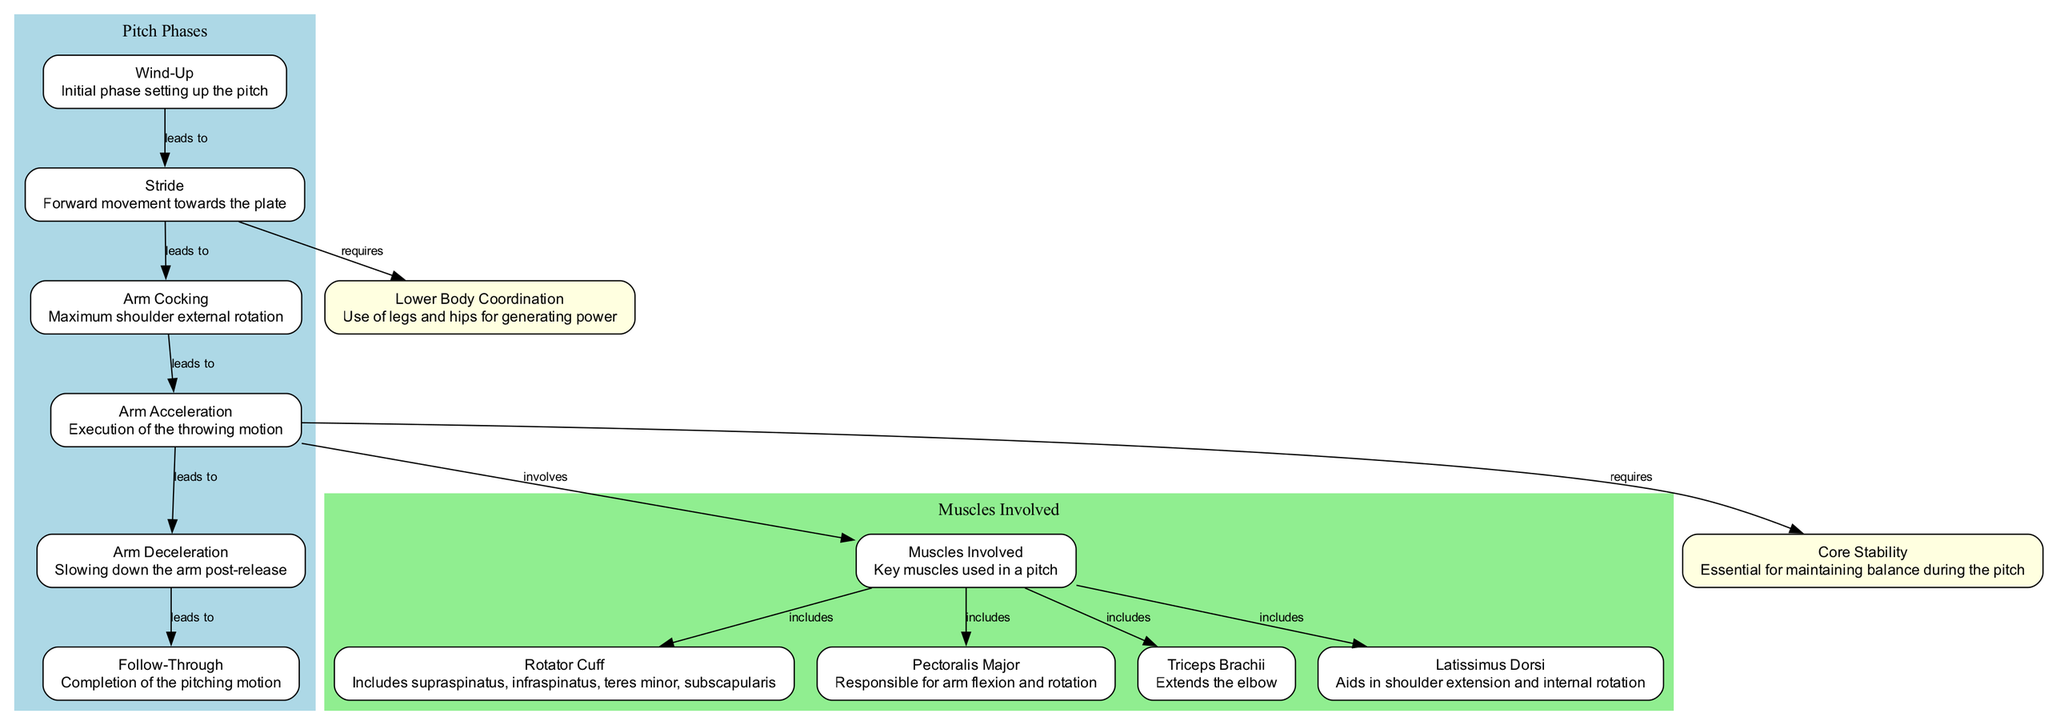What is the first phase of the pitch? The diagram identifies the first phase of the pitch as "Wind-Up," which prepares the body for the throwing motion.
Answer: Wind-Up How many muscles are included in the "Muscles Involved" section? The diagram lists four specific muscles under the "Muscles Involved" node, which are the Rotator Cuff, Pectoralis Major, Triceps Brachii, and Latissimus Dorsi.
Answer: Four What does "Arm Acceleration" lead to? According to the diagram, "Arm Acceleration" leads to "Arm Deceleration," indicating the next step in the pitching motion after acceleration.
Answer: Arm Deceleration Which phase of the pitch requires lower body coordination? The diagram shows that "Stride," which is the forward movement towards the plate, requires lower body coordination to generate power for the pitch.
Answer: Stride What muscle is responsible for arm flexion and rotation? The diagram explicitly labels "Pectoralis Major" as the muscle responsible for arm flexion and rotation during the pitching motion.
Answer: Pectoralis Major Which two elements are required during "Arm Acceleration"? The diagram indicates that both "Lower Body Coordination" and "Core Stability" are necessary for the proper execution of "Arm Acceleration."
Answer: Lower Body Coordination and Core Stability What does the "Follow-Through" phase complete? The "Follow-Through" phase in the diagram represents the final step of the pitching motion, indicating the end of the entire pitch process.
Answer: Completion of the pitching motion What is the function of the Rotator Cuff? The diagram describes the Rotator Cuff as including supraspinatus, infraspinatus, teres minor, and subscapularis, which work together to support shoulder stability and movement during the pitch.
Answer: Support shoulder stability and movement How does the "Arm Cocking" phase position the shoulder? The diagram indicates that "Arm Cocking" is characterized by maximum shoulder external rotation, which is crucial for preparing for an effective pitch.
Answer: Maximum shoulder external rotation 